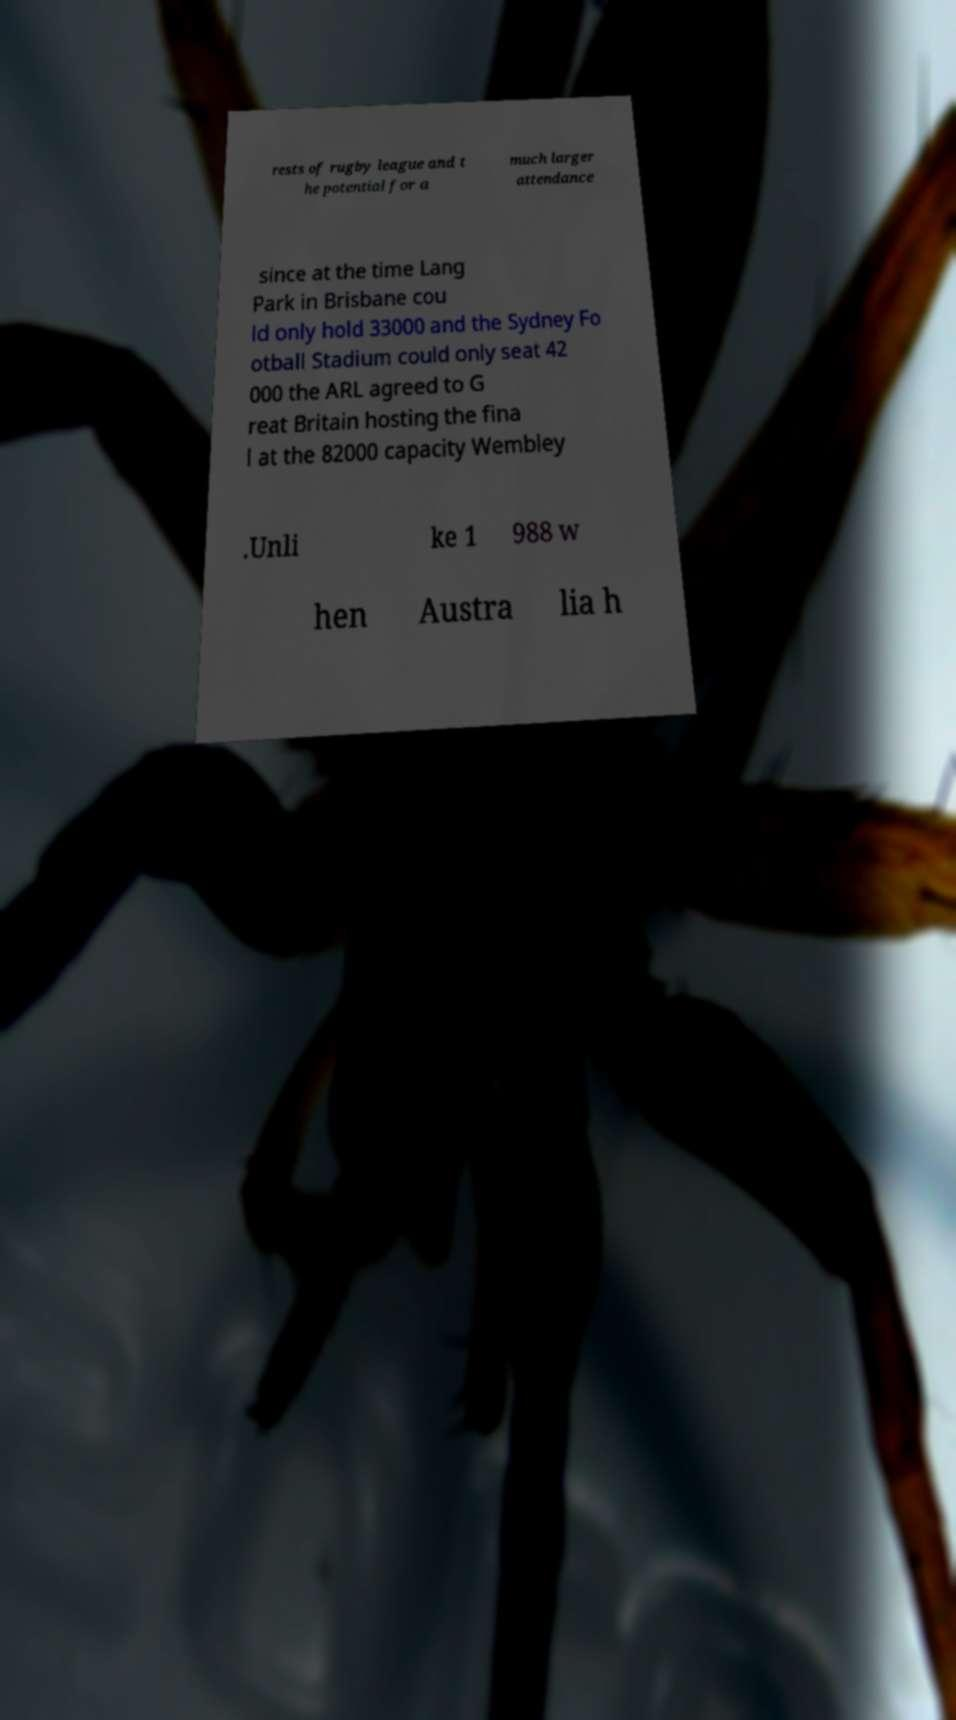I need the written content from this picture converted into text. Can you do that? rests of rugby league and t he potential for a much larger attendance since at the time Lang Park in Brisbane cou ld only hold 33000 and the Sydney Fo otball Stadium could only seat 42 000 the ARL agreed to G reat Britain hosting the fina l at the 82000 capacity Wembley .Unli ke 1 988 w hen Austra lia h 